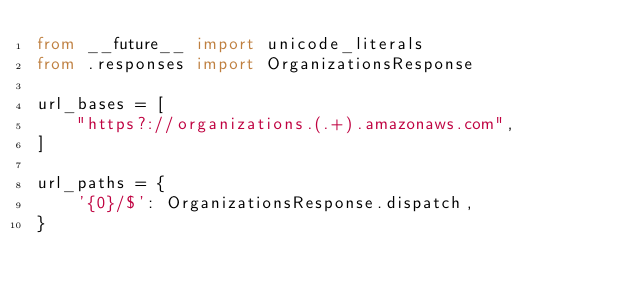Convert code to text. <code><loc_0><loc_0><loc_500><loc_500><_Python_>from __future__ import unicode_literals
from .responses import OrganizationsResponse

url_bases = [
    "https?://organizations.(.+).amazonaws.com",
]

url_paths = {
    '{0}/$': OrganizationsResponse.dispatch,
}
</code> 